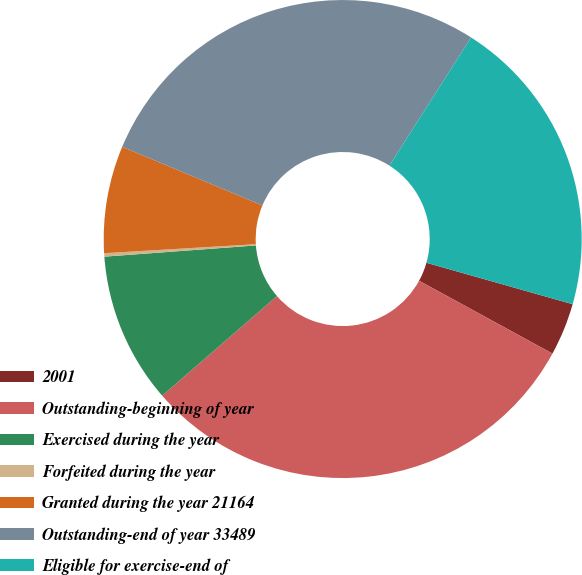Convert chart. <chart><loc_0><loc_0><loc_500><loc_500><pie_chart><fcel>2001<fcel>Outstanding-beginning of year<fcel>Exercised during the year<fcel>Forfeited during the year<fcel>Granted during the year 21164<fcel>Outstanding-end of year 33489<fcel>Eligible for exercise-end of<nl><fcel>3.56%<fcel>30.67%<fcel>10.2%<fcel>0.23%<fcel>7.25%<fcel>27.72%<fcel>20.37%<nl></chart> 